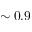<formula> <loc_0><loc_0><loc_500><loc_500>\sim 0 . 9</formula> 